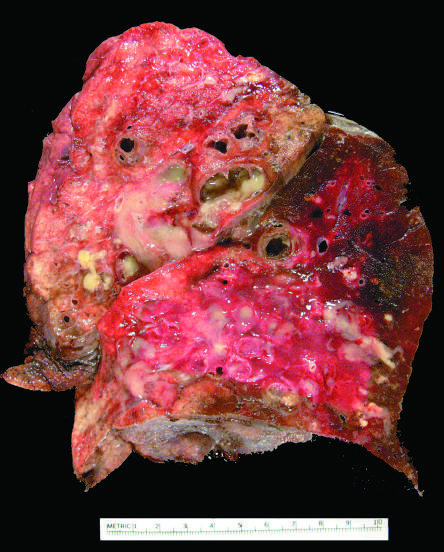does a diagnostic, binucleate reed-sternberg cell show markedly dilated bronchi filled with purulent mucus that extend to subpleural regions?
Answer the question using a single word or phrase. No 